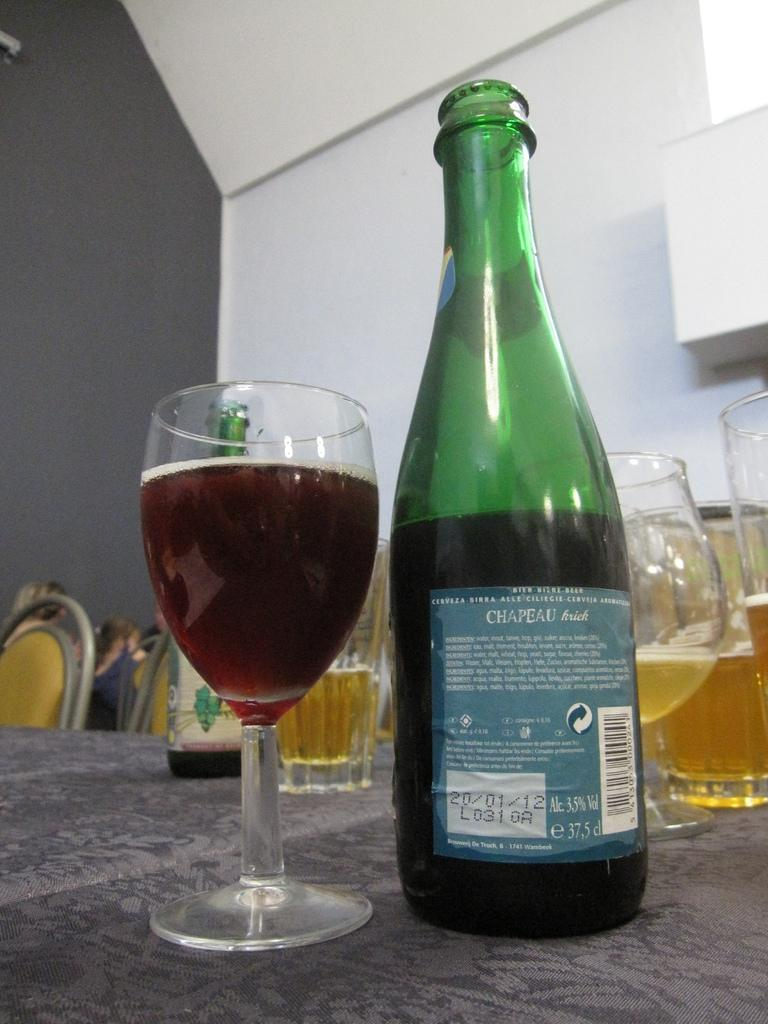What is the color of the wall in the image? The wall in the image is white. What type of furniture can be seen in the image? There are chairs and a table in the image. What objects are on the table? There are glasses and a bottle on the table. Is there a club in the image where people are smoking and discussing the value of a rare artifact? No, there is no club, smoke, or discussion about a rare artifact in the image. The image only shows a white wall, chairs, a table, glasses, and a bottle. 